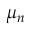<formula> <loc_0><loc_0><loc_500><loc_500>\mu _ { n }</formula> 